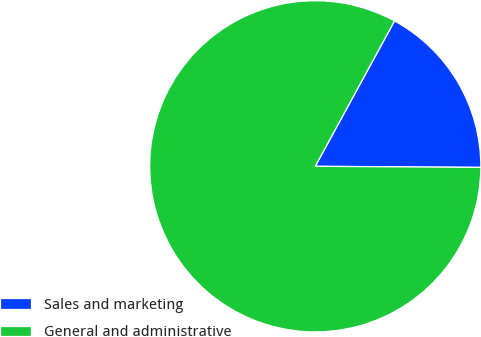Convert chart. <chart><loc_0><loc_0><loc_500><loc_500><pie_chart><fcel>Sales and marketing<fcel>General and administrative<nl><fcel>17.16%<fcel>82.84%<nl></chart> 